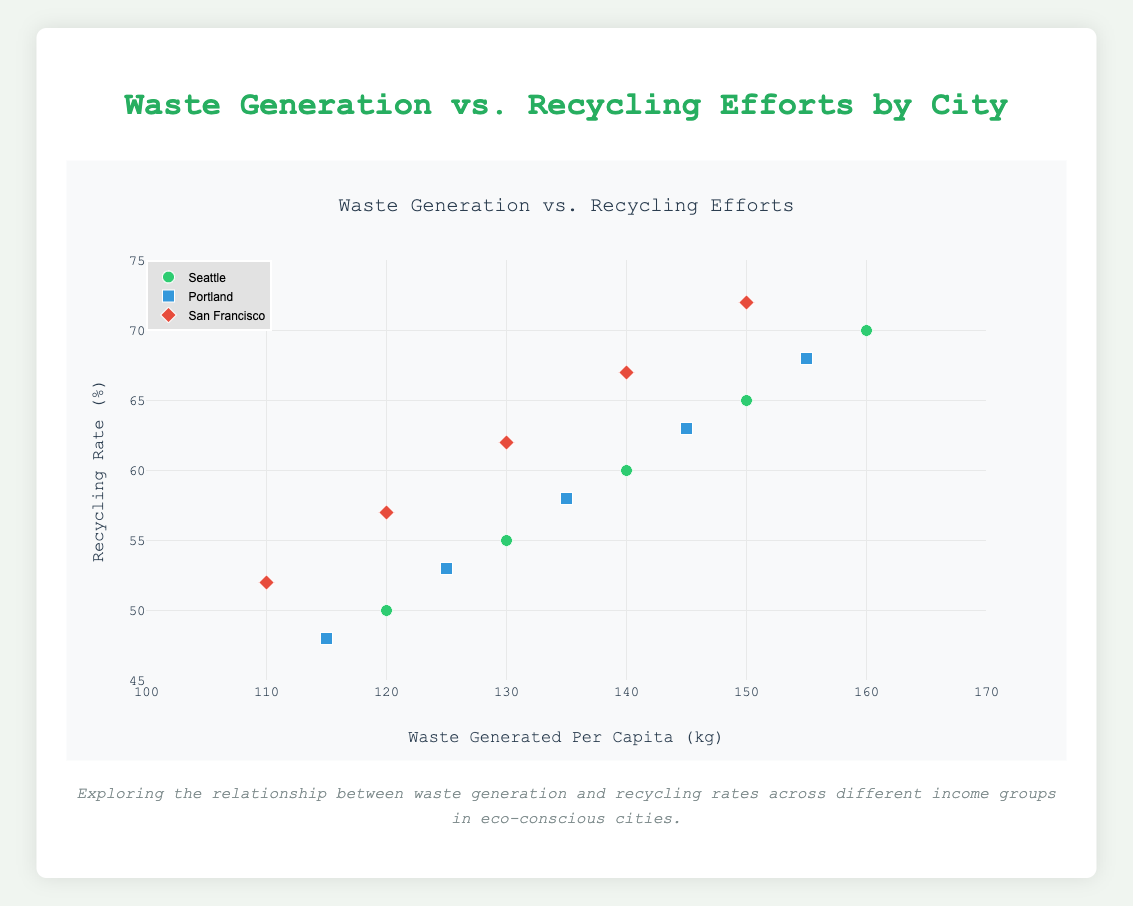What's the title of the plot? The title is given at the top of the plot, which is "Waste Generation vs. Recycling Efforts". Simply read the title from the plot.
Answer: Waste Generation vs. Recycling Efforts How many cities are represented in the plot? There are three colors and symbols representing different cities. The legend shows the city names corresponding to these colors and symbols.
Answer: Three Which city has the highest waste generation per capita for households with an income above $100,000? By looking at the highest x-value for data points with the "Above $100,000" label, we can see this value is highest for Seattle.
Answer: Seattle What is the recycling rate for Portland households earning between $50,000 and $75,000? Find the point labeled "$50,000 - $75,000" for Portland and read the y-axis value associated with it.
Answer: 58% Compare the waste generated per capita for households earning under $25,000 in Seattle and San Francisco. Which city generates more waste? Look at the "Under $25,000" points for both cities and compare their x-values. Seattle shows a higher value compared to San Francisco.
Answer: Seattle What pattern can you observe between household income and recycling rate within the same city? Observing the points per city, we notice an upward trend in recycling rate as household income increases.
Answer: Higher income usually corresponds to higher recycling rates What is the average waste generated per capita across all households in San Francisco? Sum the waste generated per capita for all income ranges in San Francisco and divide by the number of income ranges (110 + 120 + 130 + 140 + 150) / 5 = 650 / 5.
Answer: 130 kg Is there a city where recycling rates exceed 70%? If yes, which one? Look for any data points above 70% on the y-axis. Only San Francisco has a point (above $100,000) with a recycling rate of 72%.
Answer: Yes, San Francisco How does the waste generation per capita for households earning between $25,000 and $50,000 in Seattle compare to Portland? Compare the x-values for the "$25,000 - $50,000" points in both cities. Seattle's value is 130 kg, while Portland's is 125 kg—Seattle generates more.
Answer: Seattle generates more 